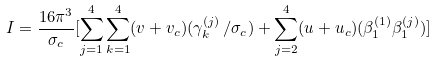<formula> <loc_0><loc_0><loc_500><loc_500>I = \frac { 1 6 \pi ^ { 3 } } { \sigma _ { c } } [ \sum _ { j = 1 } ^ { 4 } \sum _ { k = 1 } ^ { 4 } ( v + v _ { c } ) ( \gamma _ { k } ^ { ( j ) } \, / \sigma _ { c } ) + \sum _ { j = 2 } ^ { 4 } ( u + u _ { c } ) ( \beta _ { 1 } ^ { ( 1 ) } \beta _ { 1 } ^ { ( j ) } ) ]</formula> 